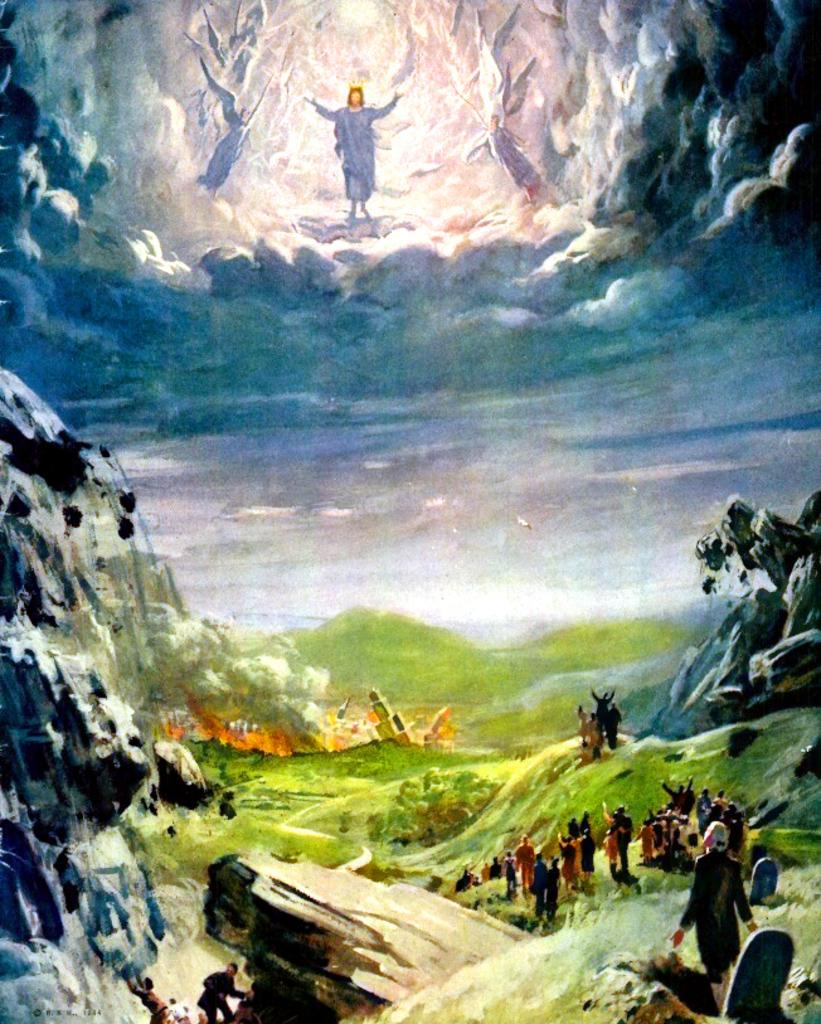What is the main subject of the image? The image contains an art piece. What is depicted in the art piece? The art piece depicts a few people. What type of terrain is visible in the art piece? There is ground visible in the art piece. What natural feature is present in the art piece? Mountains are present in the art piece. What part of the natural environment is visible in the art piece? The sky is visible in the art piece. What are the clouds like in the art piece? Clouds are present in the sky of the art piece. What type of plantation can be seen in the art piece? There is no plantation present in the art piece; it depicts people, mountains, and a sky with clouds. 